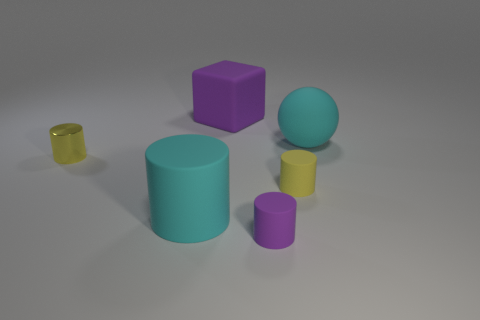There is a yellow object that is the same size as the yellow rubber cylinder; what material is it?
Make the answer very short. Metal. There is a purple rubber thing behind the big cylinder that is in front of the large purple object that is behind the large cyan rubber cylinder; what size is it?
Keep it short and to the point. Large. What is the size of the rubber cylinder that is on the left side of the large purple block?
Offer a very short reply. Large. How many objects are behind the yellow metallic object and in front of the yellow metallic cylinder?
Your response must be concise. 0. What material is the big cyan object behind the object left of the large cyan cylinder made of?
Offer a very short reply. Rubber. What is the material of the large cyan thing that is the same shape as the tiny purple object?
Your answer should be compact. Rubber. Are any tiny brown cubes visible?
Provide a succinct answer. No. There is a yellow thing that is the same material as the big purple cube; what shape is it?
Your answer should be compact. Cylinder. What material is the tiny yellow thing on the right side of the large cyan cylinder?
Your answer should be very brief. Rubber. Do the cylinder that is left of the big rubber cylinder and the block have the same color?
Offer a terse response. No. 